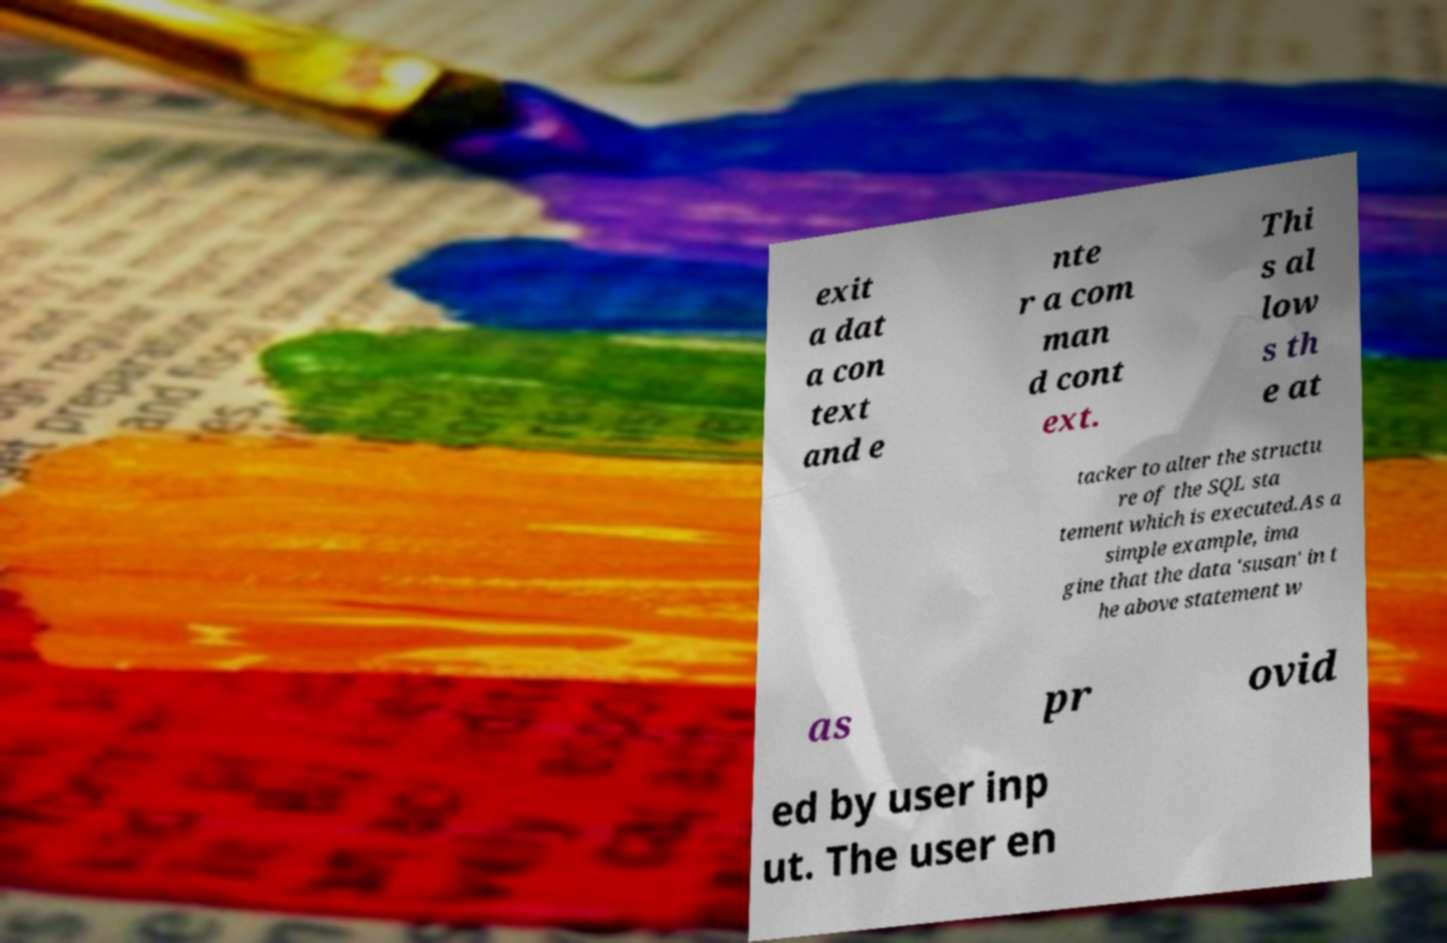Could you extract and type out the text from this image? exit a dat a con text and e nte r a com man d cont ext. Thi s al low s th e at tacker to alter the structu re of the SQL sta tement which is executed.As a simple example, ima gine that the data 'susan' in t he above statement w as pr ovid ed by user inp ut. The user en 